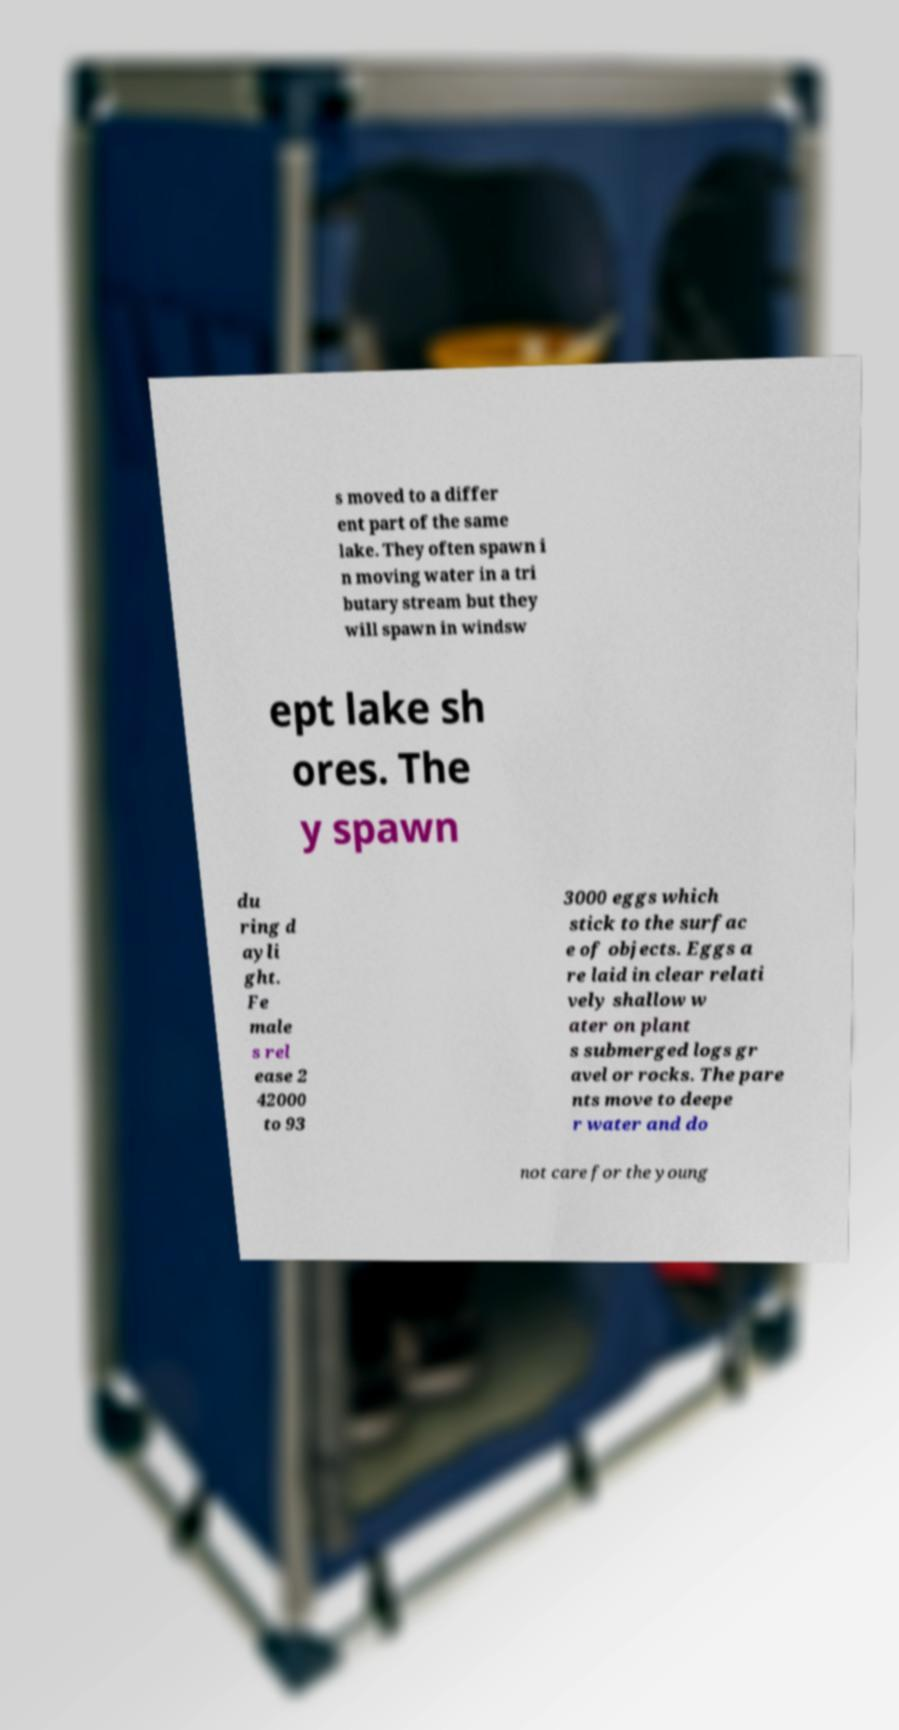What messages or text are displayed in this image? I need them in a readable, typed format. s moved to a differ ent part of the same lake. They often spawn i n moving water in a tri butary stream but they will spawn in windsw ept lake sh ores. The y spawn du ring d ayli ght. Fe male s rel ease 2 42000 to 93 3000 eggs which stick to the surfac e of objects. Eggs a re laid in clear relati vely shallow w ater on plant s submerged logs gr avel or rocks. The pare nts move to deepe r water and do not care for the young 